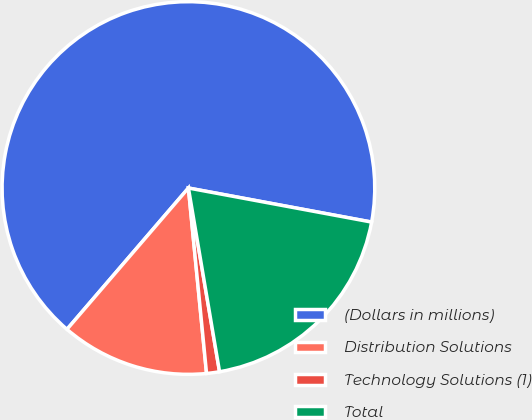Convert chart. <chart><loc_0><loc_0><loc_500><loc_500><pie_chart><fcel>(Dollars in millions)<fcel>Distribution Solutions<fcel>Technology Solutions (1)<fcel>Total<nl><fcel>66.62%<fcel>12.85%<fcel>1.12%<fcel>19.4%<nl></chart> 